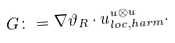<formula> <loc_0><loc_0><loc_500><loc_500>G \colon = \nabla \vartheta _ { R } \cdot u _ { l o c , h a r m } ^ { u \otimes u } .</formula> 